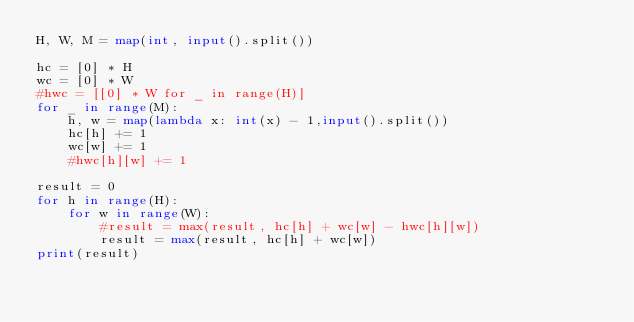<code> <loc_0><loc_0><loc_500><loc_500><_Python_>H, W, M = map(int, input().split())

hc = [0] * H
wc = [0] * W
#hwc = [[0] * W for _ in range(H)]
for _ in range(M):
    h, w = map(lambda x: int(x) - 1,input().split())
    hc[h] += 1
    wc[w] += 1
    #hwc[h][w] += 1

result = 0
for h in range(H):
    for w in range(W):
        #result = max(result, hc[h] + wc[w] - hwc[h][w])
        result = max(result, hc[h] + wc[w])
print(result)
</code> 